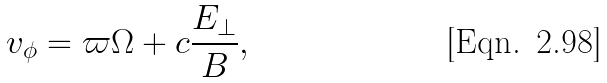Convert formula to latex. <formula><loc_0><loc_0><loc_500><loc_500>v _ { \phi } = \varpi \Omega + c \frac { E _ { \perp } } { B } ,</formula> 